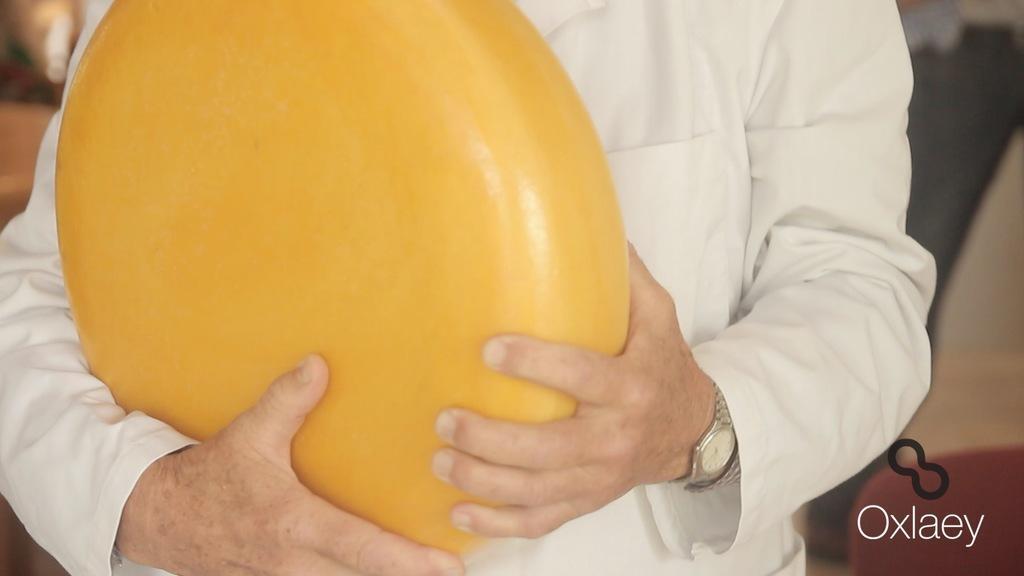In one or two sentences, can you explain what this image depicts? In this image we can see a person holding some object in his hand. There is some text written at the bottom of the image. 